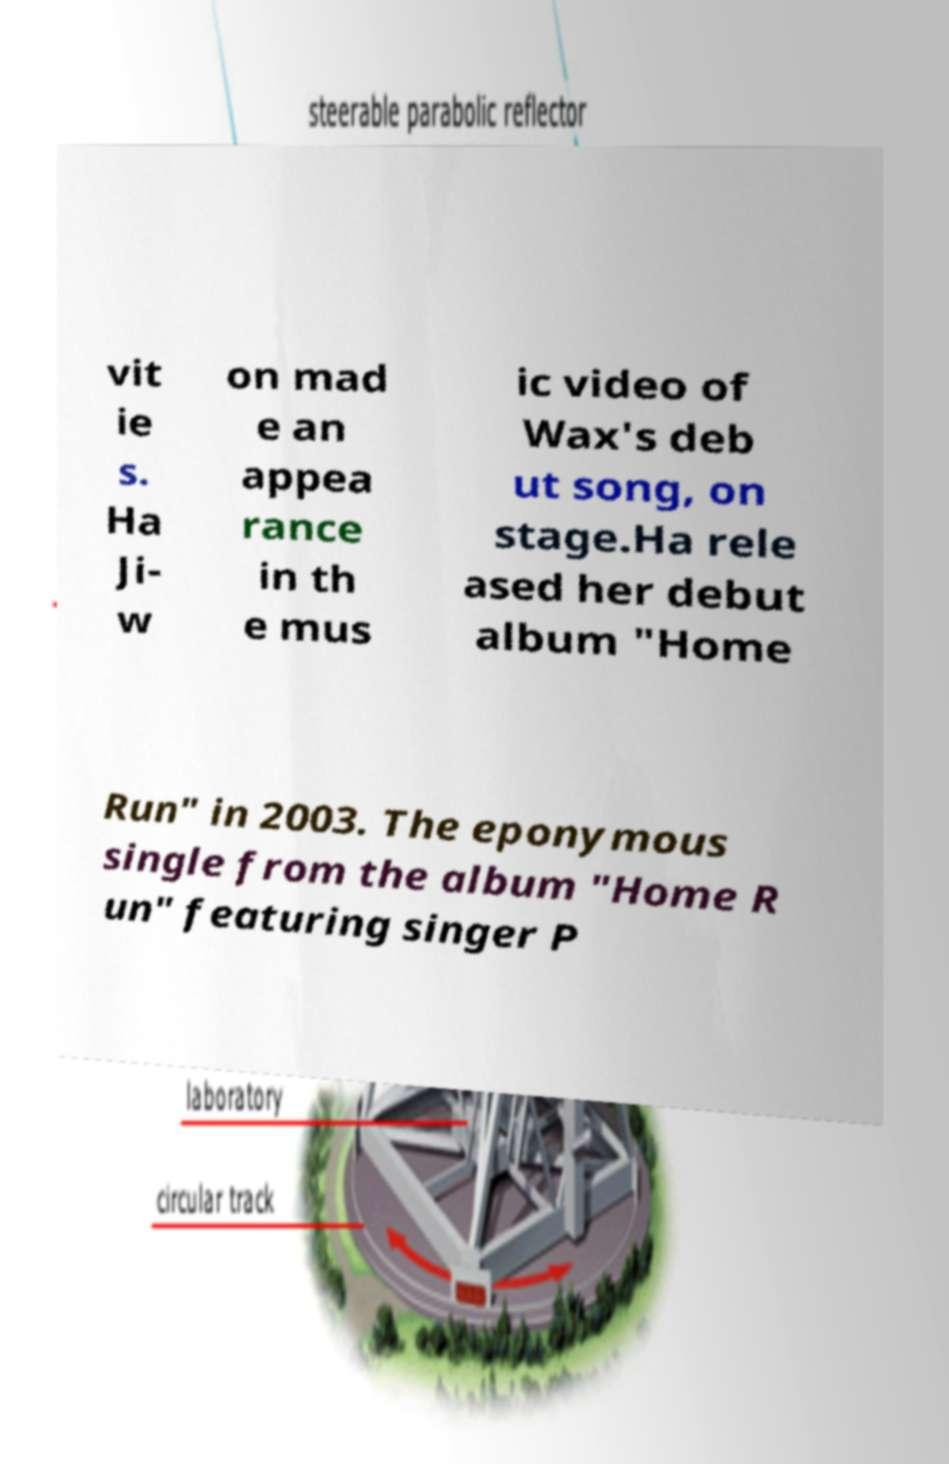There's text embedded in this image that I need extracted. Can you transcribe it verbatim? vit ie s. Ha Ji- w on mad e an appea rance in th e mus ic video of Wax's deb ut song, on stage.Ha rele ased her debut album "Home Run" in 2003. The eponymous single from the album "Home R un" featuring singer P 